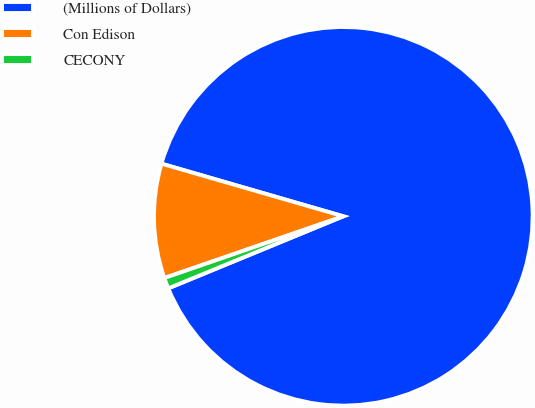Convert chart. <chart><loc_0><loc_0><loc_500><loc_500><pie_chart><fcel>(Millions of Dollars)<fcel>Con Edison<fcel>CECONY<nl><fcel>89.3%<fcel>9.77%<fcel>0.93%<nl></chart> 